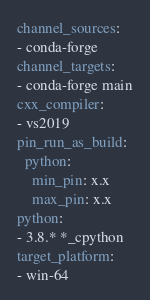<code> <loc_0><loc_0><loc_500><loc_500><_YAML_>channel_sources:
- conda-forge
channel_targets:
- conda-forge main
cxx_compiler:
- vs2019
pin_run_as_build:
  python:
    min_pin: x.x
    max_pin: x.x
python:
- 3.8.* *_cpython
target_platform:
- win-64
</code> 